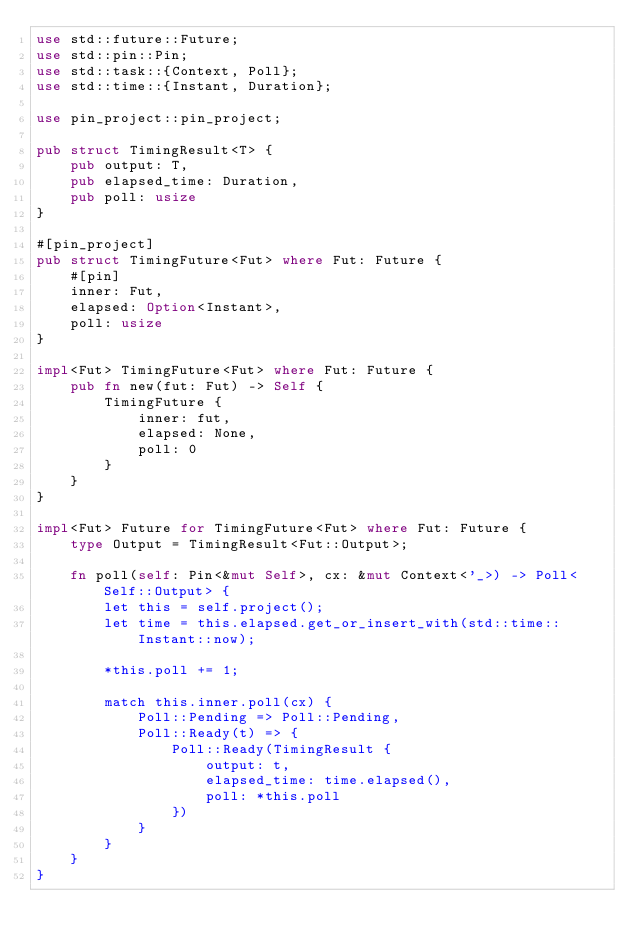Convert code to text. <code><loc_0><loc_0><loc_500><loc_500><_Rust_>use std::future::Future;
use std::pin::Pin;
use std::task::{Context, Poll};
use std::time::{Instant, Duration};

use pin_project::pin_project;

pub struct TimingResult<T> {
    pub output: T,
    pub elapsed_time: Duration,
    pub poll: usize
}

#[pin_project]
pub struct TimingFuture<Fut> where Fut: Future {
    #[pin]
    inner: Fut,
    elapsed: Option<Instant>,
    poll: usize
}

impl<Fut> TimingFuture<Fut> where Fut: Future {
    pub fn new(fut: Fut) -> Self {
        TimingFuture {
            inner: fut,
            elapsed: None,
            poll: 0
        }
    }
}

impl<Fut> Future for TimingFuture<Fut> where Fut: Future {
    type Output = TimingResult<Fut::Output>;

    fn poll(self: Pin<&mut Self>, cx: &mut Context<'_>) -> Poll<Self::Output> {
        let this = self.project();
        let time = this.elapsed.get_or_insert_with(std::time::Instant::now);

        *this.poll += 1;

        match this.inner.poll(cx) {
            Poll::Pending => Poll::Pending,
            Poll::Ready(t) => {
                Poll::Ready(TimingResult {
                    output: t,
                    elapsed_time: time.elapsed(),
                    poll: *this.poll
                })
            }
        }
    }
}</code> 